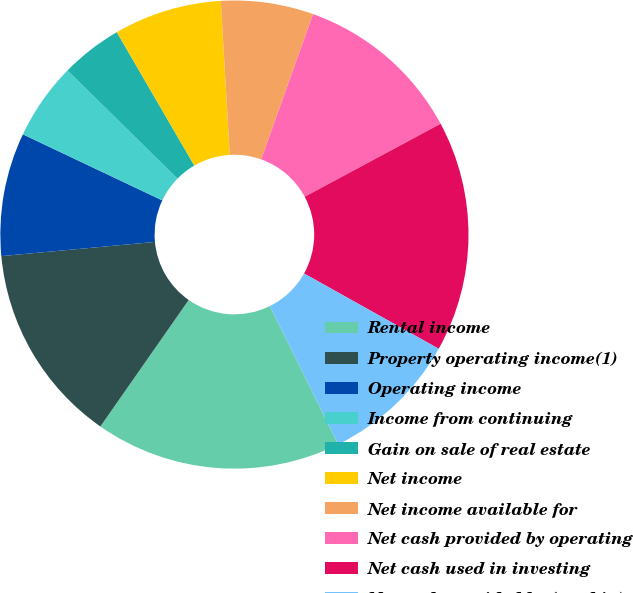Convert chart. <chart><loc_0><loc_0><loc_500><loc_500><pie_chart><fcel>Rental income<fcel>Property operating income(1)<fcel>Operating income<fcel>Income from continuing<fcel>Gain on sale of real estate<fcel>Net income<fcel>Net income available for<fcel>Net cash provided by operating<fcel>Net cash used in investing<fcel>Net cash provided by (used in)<nl><fcel>17.02%<fcel>13.83%<fcel>8.51%<fcel>5.32%<fcel>4.26%<fcel>7.45%<fcel>6.38%<fcel>11.7%<fcel>15.96%<fcel>9.57%<nl></chart> 